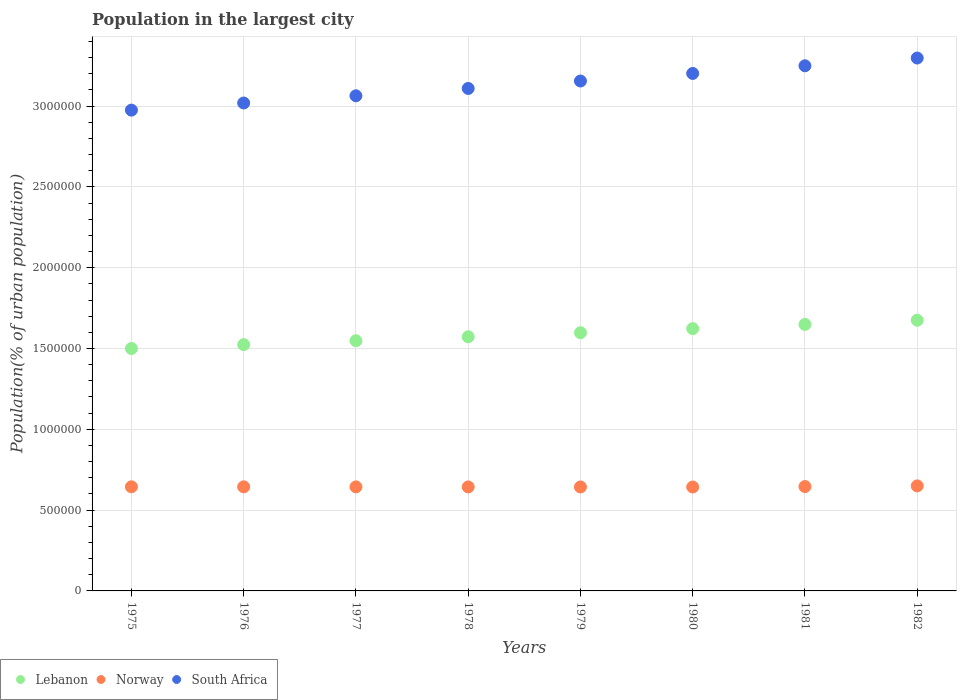How many different coloured dotlines are there?
Offer a very short reply. 3. What is the population in the largest city in Norway in 1982?
Your response must be concise. 6.50e+05. Across all years, what is the maximum population in the largest city in Norway?
Make the answer very short. 6.50e+05. Across all years, what is the minimum population in the largest city in Lebanon?
Give a very brief answer. 1.50e+06. In which year was the population in the largest city in Norway maximum?
Offer a terse response. 1982. In which year was the population in the largest city in Norway minimum?
Offer a very short reply. 1980. What is the total population in the largest city in Norway in the graph?
Give a very brief answer. 5.16e+06. What is the difference between the population in the largest city in Norway in 1976 and that in 1978?
Keep it short and to the point. 491. What is the difference between the population in the largest city in Lebanon in 1981 and the population in the largest city in Norway in 1976?
Give a very brief answer. 1.00e+06. What is the average population in the largest city in Norway per year?
Your answer should be very brief. 6.45e+05. In the year 1980, what is the difference between the population in the largest city in South Africa and population in the largest city in Lebanon?
Provide a succinct answer. 1.58e+06. What is the ratio of the population in the largest city in Norway in 1976 to that in 1978?
Provide a short and direct response. 1. Is the population in the largest city in South Africa in 1977 less than that in 1982?
Your response must be concise. Yes. Is the difference between the population in the largest city in South Africa in 1978 and 1980 greater than the difference between the population in the largest city in Lebanon in 1978 and 1980?
Offer a terse response. No. What is the difference between the highest and the second highest population in the largest city in Norway?
Make the answer very short. 4151. What is the difference between the highest and the lowest population in the largest city in South Africa?
Your answer should be compact. 3.22e+05. In how many years, is the population in the largest city in Norway greater than the average population in the largest city in Norway taken over all years?
Your response must be concise. 2. Is the population in the largest city in Lebanon strictly greater than the population in the largest city in South Africa over the years?
Your answer should be very brief. No. Is the population in the largest city in Norway strictly less than the population in the largest city in South Africa over the years?
Provide a succinct answer. Yes. How many dotlines are there?
Provide a short and direct response. 3. Does the graph contain grids?
Give a very brief answer. Yes. Where does the legend appear in the graph?
Keep it short and to the point. Bottom left. How many legend labels are there?
Your response must be concise. 3. What is the title of the graph?
Your response must be concise. Population in the largest city. Does "Lesotho" appear as one of the legend labels in the graph?
Offer a very short reply. No. What is the label or title of the X-axis?
Your answer should be compact. Years. What is the label or title of the Y-axis?
Provide a short and direct response. Population(% of urban population). What is the Population(% of urban population) in Lebanon in 1975?
Ensure brevity in your answer.  1.50e+06. What is the Population(% of urban population) of Norway in 1975?
Your answer should be very brief. 6.44e+05. What is the Population(% of urban population) of South Africa in 1975?
Your answer should be very brief. 2.97e+06. What is the Population(% of urban population) of Lebanon in 1976?
Your answer should be compact. 1.52e+06. What is the Population(% of urban population) in Norway in 1976?
Ensure brevity in your answer.  6.44e+05. What is the Population(% of urban population) in South Africa in 1976?
Your response must be concise. 3.02e+06. What is the Population(% of urban population) of Lebanon in 1977?
Offer a terse response. 1.55e+06. What is the Population(% of urban population) of Norway in 1977?
Offer a very short reply. 6.44e+05. What is the Population(% of urban population) of South Africa in 1977?
Offer a very short reply. 3.06e+06. What is the Population(% of urban population) of Lebanon in 1978?
Give a very brief answer. 1.57e+06. What is the Population(% of urban population) of Norway in 1978?
Provide a short and direct response. 6.44e+05. What is the Population(% of urban population) in South Africa in 1978?
Offer a terse response. 3.11e+06. What is the Population(% of urban population) in Lebanon in 1979?
Make the answer very short. 1.60e+06. What is the Population(% of urban population) of Norway in 1979?
Give a very brief answer. 6.43e+05. What is the Population(% of urban population) in South Africa in 1979?
Offer a very short reply. 3.16e+06. What is the Population(% of urban population) in Lebanon in 1980?
Your response must be concise. 1.62e+06. What is the Population(% of urban population) in Norway in 1980?
Keep it short and to the point. 6.43e+05. What is the Population(% of urban population) of South Africa in 1980?
Provide a short and direct response. 3.20e+06. What is the Population(% of urban population) of Lebanon in 1981?
Offer a very short reply. 1.65e+06. What is the Population(% of urban population) of Norway in 1981?
Your answer should be compact. 6.46e+05. What is the Population(% of urban population) of South Africa in 1981?
Your answer should be compact. 3.25e+06. What is the Population(% of urban population) in Lebanon in 1982?
Your response must be concise. 1.68e+06. What is the Population(% of urban population) in Norway in 1982?
Offer a terse response. 6.50e+05. What is the Population(% of urban population) in South Africa in 1982?
Give a very brief answer. 3.30e+06. Across all years, what is the maximum Population(% of urban population) of Lebanon?
Make the answer very short. 1.68e+06. Across all years, what is the maximum Population(% of urban population) of Norway?
Offer a terse response. 6.50e+05. Across all years, what is the maximum Population(% of urban population) of South Africa?
Provide a succinct answer. 3.30e+06. Across all years, what is the minimum Population(% of urban population) of Lebanon?
Your answer should be compact. 1.50e+06. Across all years, what is the minimum Population(% of urban population) in Norway?
Your answer should be very brief. 6.43e+05. Across all years, what is the minimum Population(% of urban population) in South Africa?
Your response must be concise. 2.97e+06. What is the total Population(% of urban population) in Lebanon in the graph?
Make the answer very short. 1.27e+07. What is the total Population(% of urban population) in Norway in the graph?
Offer a terse response. 5.16e+06. What is the total Population(% of urban population) of South Africa in the graph?
Ensure brevity in your answer.  2.51e+07. What is the difference between the Population(% of urban population) of Lebanon in 1975 and that in 1976?
Make the answer very short. -2.39e+04. What is the difference between the Population(% of urban population) of Norway in 1975 and that in 1976?
Make the answer very short. 246. What is the difference between the Population(% of urban population) in South Africa in 1975 and that in 1976?
Give a very brief answer. -4.41e+04. What is the difference between the Population(% of urban population) of Lebanon in 1975 and that in 1977?
Offer a very short reply. -4.80e+04. What is the difference between the Population(% of urban population) in Norway in 1975 and that in 1977?
Your answer should be very brief. 491. What is the difference between the Population(% of urban population) of South Africa in 1975 and that in 1977?
Offer a terse response. -8.88e+04. What is the difference between the Population(% of urban population) of Lebanon in 1975 and that in 1978?
Ensure brevity in your answer.  -7.26e+04. What is the difference between the Population(% of urban population) in Norway in 1975 and that in 1978?
Provide a short and direct response. 737. What is the difference between the Population(% of urban population) of South Africa in 1975 and that in 1978?
Make the answer very short. -1.34e+05. What is the difference between the Population(% of urban population) of Lebanon in 1975 and that in 1979?
Your answer should be very brief. -9.76e+04. What is the difference between the Population(% of urban population) of Norway in 1975 and that in 1979?
Ensure brevity in your answer.  983. What is the difference between the Population(% of urban population) in South Africa in 1975 and that in 1979?
Keep it short and to the point. -1.80e+05. What is the difference between the Population(% of urban population) of Lebanon in 1975 and that in 1980?
Ensure brevity in your answer.  -1.23e+05. What is the difference between the Population(% of urban population) in Norway in 1975 and that in 1980?
Offer a terse response. 1229. What is the difference between the Population(% of urban population) of South Africa in 1975 and that in 1980?
Offer a terse response. -2.27e+05. What is the difference between the Population(% of urban population) of Lebanon in 1975 and that in 1981?
Provide a short and direct response. -1.49e+05. What is the difference between the Population(% of urban population) of Norway in 1975 and that in 1981?
Offer a terse response. -1425. What is the difference between the Population(% of urban population) of South Africa in 1975 and that in 1981?
Offer a very short reply. -2.74e+05. What is the difference between the Population(% of urban population) of Lebanon in 1975 and that in 1982?
Your response must be concise. -1.75e+05. What is the difference between the Population(% of urban population) of Norway in 1975 and that in 1982?
Your answer should be compact. -5576. What is the difference between the Population(% of urban population) in South Africa in 1975 and that in 1982?
Provide a short and direct response. -3.22e+05. What is the difference between the Population(% of urban population) of Lebanon in 1976 and that in 1977?
Give a very brief answer. -2.42e+04. What is the difference between the Population(% of urban population) in Norway in 1976 and that in 1977?
Ensure brevity in your answer.  245. What is the difference between the Population(% of urban population) in South Africa in 1976 and that in 1977?
Provide a short and direct response. -4.46e+04. What is the difference between the Population(% of urban population) of Lebanon in 1976 and that in 1978?
Make the answer very short. -4.88e+04. What is the difference between the Population(% of urban population) of Norway in 1976 and that in 1978?
Provide a succinct answer. 491. What is the difference between the Population(% of urban population) of South Africa in 1976 and that in 1978?
Keep it short and to the point. -9.00e+04. What is the difference between the Population(% of urban population) in Lebanon in 1976 and that in 1979?
Keep it short and to the point. -7.38e+04. What is the difference between the Population(% of urban population) in Norway in 1976 and that in 1979?
Offer a terse response. 737. What is the difference between the Population(% of urban population) in South Africa in 1976 and that in 1979?
Offer a terse response. -1.36e+05. What is the difference between the Population(% of urban population) in Lebanon in 1976 and that in 1980?
Give a very brief answer. -9.92e+04. What is the difference between the Population(% of urban population) in Norway in 1976 and that in 1980?
Offer a terse response. 983. What is the difference between the Population(% of urban population) of South Africa in 1976 and that in 1980?
Ensure brevity in your answer.  -1.83e+05. What is the difference between the Population(% of urban population) in Lebanon in 1976 and that in 1981?
Ensure brevity in your answer.  -1.25e+05. What is the difference between the Population(% of urban population) in Norway in 1976 and that in 1981?
Give a very brief answer. -1671. What is the difference between the Population(% of urban population) in South Africa in 1976 and that in 1981?
Keep it short and to the point. -2.30e+05. What is the difference between the Population(% of urban population) in Lebanon in 1976 and that in 1982?
Keep it short and to the point. -1.51e+05. What is the difference between the Population(% of urban population) in Norway in 1976 and that in 1982?
Your answer should be compact. -5822. What is the difference between the Population(% of urban population) in South Africa in 1976 and that in 1982?
Offer a very short reply. -2.78e+05. What is the difference between the Population(% of urban population) of Lebanon in 1977 and that in 1978?
Keep it short and to the point. -2.46e+04. What is the difference between the Population(% of urban population) in Norway in 1977 and that in 1978?
Make the answer very short. 246. What is the difference between the Population(% of urban population) of South Africa in 1977 and that in 1978?
Make the answer very short. -4.54e+04. What is the difference between the Population(% of urban population) in Lebanon in 1977 and that in 1979?
Your response must be concise. -4.96e+04. What is the difference between the Population(% of urban population) in Norway in 1977 and that in 1979?
Provide a short and direct response. 492. What is the difference between the Population(% of urban population) of South Africa in 1977 and that in 1979?
Provide a short and direct response. -9.14e+04. What is the difference between the Population(% of urban population) in Lebanon in 1977 and that in 1980?
Give a very brief answer. -7.50e+04. What is the difference between the Population(% of urban population) in Norway in 1977 and that in 1980?
Give a very brief answer. 738. What is the difference between the Population(% of urban population) of South Africa in 1977 and that in 1980?
Ensure brevity in your answer.  -1.38e+05. What is the difference between the Population(% of urban population) of Lebanon in 1977 and that in 1981?
Make the answer very short. -1.01e+05. What is the difference between the Population(% of urban population) in Norway in 1977 and that in 1981?
Provide a succinct answer. -1916. What is the difference between the Population(% of urban population) of South Africa in 1977 and that in 1981?
Your answer should be compact. -1.86e+05. What is the difference between the Population(% of urban population) in Lebanon in 1977 and that in 1982?
Keep it short and to the point. -1.27e+05. What is the difference between the Population(% of urban population) of Norway in 1977 and that in 1982?
Your response must be concise. -6067. What is the difference between the Population(% of urban population) in South Africa in 1977 and that in 1982?
Ensure brevity in your answer.  -2.34e+05. What is the difference between the Population(% of urban population) of Lebanon in 1978 and that in 1979?
Your answer should be very brief. -2.50e+04. What is the difference between the Population(% of urban population) of Norway in 1978 and that in 1979?
Give a very brief answer. 246. What is the difference between the Population(% of urban population) of South Africa in 1978 and that in 1979?
Keep it short and to the point. -4.60e+04. What is the difference between the Population(% of urban population) in Lebanon in 1978 and that in 1980?
Provide a short and direct response. -5.04e+04. What is the difference between the Population(% of urban population) of Norway in 1978 and that in 1980?
Provide a succinct answer. 492. What is the difference between the Population(% of urban population) of South Africa in 1978 and that in 1980?
Your answer should be very brief. -9.28e+04. What is the difference between the Population(% of urban population) in Lebanon in 1978 and that in 1981?
Offer a terse response. -7.62e+04. What is the difference between the Population(% of urban population) in Norway in 1978 and that in 1981?
Give a very brief answer. -2162. What is the difference between the Population(% of urban population) in South Africa in 1978 and that in 1981?
Offer a terse response. -1.40e+05. What is the difference between the Population(% of urban population) of Lebanon in 1978 and that in 1982?
Your answer should be very brief. -1.02e+05. What is the difference between the Population(% of urban population) of Norway in 1978 and that in 1982?
Make the answer very short. -6313. What is the difference between the Population(% of urban population) of South Africa in 1978 and that in 1982?
Your response must be concise. -1.88e+05. What is the difference between the Population(% of urban population) of Lebanon in 1979 and that in 1980?
Your answer should be very brief. -2.54e+04. What is the difference between the Population(% of urban population) of Norway in 1979 and that in 1980?
Give a very brief answer. 246. What is the difference between the Population(% of urban population) of South Africa in 1979 and that in 1980?
Ensure brevity in your answer.  -4.68e+04. What is the difference between the Population(% of urban population) in Lebanon in 1979 and that in 1981?
Keep it short and to the point. -5.12e+04. What is the difference between the Population(% of urban population) of Norway in 1979 and that in 1981?
Provide a succinct answer. -2408. What is the difference between the Population(% of urban population) of South Africa in 1979 and that in 1981?
Provide a succinct answer. -9.41e+04. What is the difference between the Population(% of urban population) of Lebanon in 1979 and that in 1982?
Offer a very short reply. -7.74e+04. What is the difference between the Population(% of urban population) of Norway in 1979 and that in 1982?
Your answer should be compact. -6559. What is the difference between the Population(% of urban population) of South Africa in 1979 and that in 1982?
Offer a very short reply. -1.42e+05. What is the difference between the Population(% of urban population) in Lebanon in 1980 and that in 1981?
Provide a succinct answer. -2.58e+04. What is the difference between the Population(% of urban population) of Norway in 1980 and that in 1981?
Make the answer very short. -2654. What is the difference between the Population(% of urban population) of South Africa in 1980 and that in 1981?
Keep it short and to the point. -4.74e+04. What is the difference between the Population(% of urban population) of Lebanon in 1980 and that in 1982?
Make the answer very short. -5.20e+04. What is the difference between the Population(% of urban population) in Norway in 1980 and that in 1982?
Provide a succinct answer. -6805. What is the difference between the Population(% of urban population) in South Africa in 1980 and that in 1982?
Your response must be concise. -9.55e+04. What is the difference between the Population(% of urban population) in Lebanon in 1981 and that in 1982?
Your answer should be compact. -2.62e+04. What is the difference between the Population(% of urban population) in Norway in 1981 and that in 1982?
Keep it short and to the point. -4151. What is the difference between the Population(% of urban population) of South Africa in 1981 and that in 1982?
Your answer should be very brief. -4.81e+04. What is the difference between the Population(% of urban population) of Lebanon in 1975 and the Population(% of urban population) of Norway in 1976?
Give a very brief answer. 8.56e+05. What is the difference between the Population(% of urban population) in Lebanon in 1975 and the Population(% of urban population) in South Africa in 1976?
Your response must be concise. -1.52e+06. What is the difference between the Population(% of urban population) of Norway in 1975 and the Population(% of urban population) of South Africa in 1976?
Provide a succinct answer. -2.37e+06. What is the difference between the Population(% of urban population) of Lebanon in 1975 and the Population(% of urban population) of Norway in 1977?
Ensure brevity in your answer.  8.56e+05. What is the difference between the Population(% of urban population) of Lebanon in 1975 and the Population(% of urban population) of South Africa in 1977?
Ensure brevity in your answer.  -1.56e+06. What is the difference between the Population(% of urban population) in Norway in 1975 and the Population(% of urban population) in South Africa in 1977?
Your response must be concise. -2.42e+06. What is the difference between the Population(% of urban population) in Lebanon in 1975 and the Population(% of urban population) in Norway in 1978?
Your answer should be very brief. 8.56e+05. What is the difference between the Population(% of urban population) of Lebanon in 1975 and the Population(% of urban population) of South Africa in 1978?
Keep it short and to the point. -1.61e+06. What is the difference between the Population(% of urban population) in Norway in 1975 and the Population(% of urban population) in South Africa in 1978?
Keep it short and to the point. -2.46e+06. What is the difference between the Population(% of urban population) of Lebanon in 1975 and the Population(% of urban population) of Norway in 1979?
Your answer should be compact. 8.57e+05. What is the difference between the Population(% of urban population) in Lebanon in 1975 and the Population(% of urban population) in South Africa in 1979?
Keep it short and to the point. -1.66e+06. What is the difference between the Population(% of urban population) of Norway in 1975 and the Population(% of urban population) of South Africa in 1979?
Your response must be concise. -2.51e+06. What is the difference between the Population(% of urban population) in Lebanon in 1975 and the Population(% of urban population) in Norway in 1980?
Ensure brevity in your answer.  8.57e+05. What is the difference between the Population(% of urban population) of Lebanon in 1975 and the Population(% of urban population) of South Africa in 1980?
Your response must be concise. -1.70e+06. What is the difference between the Population(% of urban population) of Norway in 1975 and the Population(% of urban population) of South Africa in 1980?
Give a very brief answer. -2.56e+06. What is the difference between the Population(% of urban population) of Lebanon in 1975 and the Population(% of urban population) of Norway in 1981?
Your response must be concise. 8.54e+05. What is the difference between the Population(% of urban population) of Lebanon in 1975 and the Population(% of urban population) of South Africa in 1981?
Give a very brief answer. -1.75e+06. What is the difference between the Population(% of urban population) in Norway in 1975 and the Population(% of urban population) in South Africa in 1981?
Provide a short and direct response. -2.60e+06. What is the difference between the Population(% of urban population) of Lebanon in 1975 and the Population(% of urban population) of Norway in 1982?
Your answer should be very brief. 8.50e+05. What is the difference between the Population(% of urban population) in Lebanon in 1975 and the Population(% of urban population) in South Africa in 1982?
Offer a terse response. -1.80e+06. What is the difference between the Population(% of urban population) in Norway in 1975 and the Population(% of urban population) in South Africa in 1982?
Keep it short and to the point. -2.65e+06. What is the difference between the Population(% of urban population) in Lebanon in 1976 and the Population(% of urban population) in Norway in 1977?
Offer a very short reply. 8.80e+05. What is the difference between the Population(% of urban population) of Lebanon in 1976 and the Population(% of urban population) of South Africa in 1977?
Offer a terse response. -1.54e+06. What is the difference between the Population(% of urban population) of Norway in 1976 and the Population(% of urban population) of South Africa in 1977?
Give a very brief answer. -2.42e+06. What is the difference between the Population(% of urban population) of Lebanon in 1976 and the Population(% of urban population) of Norway in 1978?
Provide a succinct answer. 8.80e+05. What is the difference between the Population(% of urban population) of Lebanon in 1976 and the Population(% of urban population) of South Africa in 1978?
Offer a very short reply. -1.59e+06. What is the difference between the Population(% of urban population) in Norway in 1976 and the Population(% of urban population) in South Africa in 1978?
Give a very brief answer. -2.47e+06. What is the difference between the Population(% of urban population) of Lebanon in 1976 and the Population(% of urban population) of Norway in 1979?
Offer a terse response. 8.81e+05. What is the difference between the Population(% of urban population) in Lebanon in 1976 and the Population(% of urban population) in South Africa in 1979?
Give a very brief answer. -1.63e+06. What is the difference between the Population(% of urban population) in Norway in 1976 and the Population(% of urban population) in South Africa in 1979?
Your answer should be compact. -2.51e+06. What is the difference between the Population(% of urban population) of Lebanon in 1976 and the Population(% of urban population) of Norway in 1980?
Ensure brevity in your answer.  8.81e+05. What is the difference between the Population(% of urban population) in Lebanon in 1976 and the Population(% of urban population) in South Africa in 1980?
Offer a terse response. -1.68e+06. What is the difference between the Population(% of urban population) in Norway in 1976 and the Population(% of urban population) in South Africa in 1980?
Make the answer very short. -2.56e+06. What is the difference between the Population(% of urban population) in Lebanon in 1976 and the Population(% of urban population) in Norway in 1981?
Offer a terse response. 8.78e+05. What is the difference between the Population(% of urban population) in Lebanon in 1976 and the Population(% of urban population) in South Africa in 1981?
Your answer should be compact. -1.73e+06. What is the difference between the Population(% of urban population) in Norway in 1976 and the Population(% of urban population) in South Africa in 1981?
Your answer should be very brief. -2.61e+06. What is the difference between the Population(% of urban population) in Lebanon in 1976 and the Population(% of urban population) in Norway in 1982?
Give a very brief answer. 8.74e+05. What is the difference between the Population(% of urban population) in Lebanon in 1976 and the Population(% of urban population) in South Africa in 1982?
Give a very brief answer. -1.77e+06. What is the difference between the Population(% of urban population) of Norway in 1976 and the Population(% of urban population) of South Africa in 1982?
Your answer should be very brief. -2.65e+06. What is the difference between the Population(% of urban population) of Lebanon in 1977 and the Population(% of urban population) of Norway in 1978?
Provide a short and direct response. 9.05e+05. What is the difference between the Population(% of urban population) in Lebanon in 1977 and the Population(% of urban population) in South Africa in 1978?
Ensure brevity in your answer.  -1.56e+06. What is the difference between the Population(% of urban population) of Norway in 1977 and the Population(% of urban population) of South Africa in 1978?
Your answer should be compact. -2.47e+06. What is the difference between the Population(% of urban population) of Lebanon in 1977 and the Population(% of urban population) of Norway in 1979?
Provide a succinct answer. 9.05e+05. What is the difference between the Population(% of urban population) of Lebanon in 1977 and the Population(% of urban population) of South Africa in 1979?
Your answer should be compact. -1.61e+06. What is the difference between the Population(% of urban population) of Norway in 1977 and the Population(% of urban population) of South Africa in 1979?
Ensure brevity in your answer.  -2.51e+06. What is the difference between the Population(% of urban population) in Lebanon in 1977 and the Population(% of urban population) in Norway in 1980?
Your answer should be very brief. 9.05e+05. What is the difference between the Population(% of urban population) in Lebanon in 1977 and the Population(% of urban population) in South Africa in 1980?
Offer a very short reply. -1.65e+06. What is the difference between the Population(% of urban population) of Norway in 1977 and the Population(% of urban population) of South Africa in 1980?
Provide a succinct answer. -2.56e+06. What is the difference between the Population(% of urban population) in Lebanon in 1977 and the Population(% of urban population) in Norway in 1981?
Offer a terse response. 9.02e+05. What is the difference between the Population(% of urban population) of Lebanon in 1977 and the Population(% of urban population) of South Africa in 1981?
Your response must be concise. -1.70e+06. What is the difference between the Population(% of urban population) of Norway in 1977 and the Population(% of urban population) of South Africa in 1981?
Your answer should be very brief. -2.61e+06. What is the difference between the Population(% of urban population) in Lebanon in 1977 and the Population(% of urban population) in Norway in 1982?
Your answer should be very brief. 8.98e+05. What is the difference between the Population(% of urban population) in Lebanon in 1977 and the Population(% of urban population) in South Africa in 1982?
Your answer should be very brief. -1.75e+06. What is the difference between the Population(% of urban population) in Norway in 1977 and the Population(% of urban population) in South Africa in 1982?
Your answer should be compact. -2.65e+06. What is the difference between the Population(% of urban population) of Lebanon in 1978 and the Population(% of urban population) of Norway in 1979?
Provide a succinct answer. 9.29e+05. What is the difference between the Population(% of urban population) of Lebanon in 1978 and the Population(% of urban population) of South Africa in 1979?
Your answer should be very brief. -1.58e+06. What is the difference between the Population(% of urban population) in Norway in 1978 and the Population(% of urban population) in South Africa in 1979?
Provide a short and direct response. -2.51e+06. What is the difference between the Population(% of urban population) in Lebanon in 1978 and the Population(% of urban population) in Norway in 1980?
Give a very brief answer. 9.30e+05. What is the difference between the Population(% of urban population) of Lebanon in 1978 and the Population(% of urban population) of South Africa in 1980?
Your answer should be compact. -1.63e+06. What is the difference between the Population(% of urban population) in Norway in 1978 and the Population(% of urban population) in South Africa in 1980?
Provide a short and direct response. -2.56e+06. What is the difference between the Population(% of urban population) in Lebanon in 1978 and the Population(% of urban population) in Norway in 1981?
Keep it short and to the point. 9.27e+05. What is the difference between the Population(% of urban population) in Lebanon in 1978 and the Population(% of urban population) in South Africa in 1981?
Offer a very short reply. -1.68e+06. What is the difference between the Population(% of urban population) of Norway in 1978 and the Population(% of urban population) of South Africa in 1981?
Offer a very short reply. -2.61e+06. What is the difference between the Population(% of urban population) in Lebanon in 1978 and the Population(% of urban population) in Norway in 1982?
Keep it short and to the point. 9.23e+05. What is the difference between the Population(% of urban population) in Lebanon in 1978 and the Population(% of urban population) in South Africa in 1982?
Make the answer very short. -1.72e+06. What is the difference between the Population(% of urban population) of Norway in 1978 and the Population(% of urban population) of South Africa in 1982?
Offer a very short reply. -2.65e+06. What is the difference between the Population(% of urban population) in Lebanon in 1979 and the Population(% of urban population) in Norway in 1980?
Your answer should be very brief. 9.55e+05. What is the difference between the Population(% of urban population) of Lebanon in 1979 and the Population(% of urban population) of South Africa in 1980?
Offer a terse response. -1.60e+06. What is the difference between the Population(% of urban population) of Norway in 1979 and the Population(% of urban population) of South Africa in 1980?
Offer a very short reply. -2.56e+06. What is the difference between the Population(% of urban population) of Lebanon in 1979 and the Population(% of urban population) of Norway in 1981?
Your answer should be very brief. 9.52e+05. What is the difference between the Population(% of urban population) of Lebanon in 1979 and the Population(% of urban population) of South Africa in 1981?
Provide a succinct answer. -1.65e+06. What is the difference between the Population(% of urban population) of Norway in 1979 and the Population(% of urban population) of South Africa in 1981?
Offer a very short reply. -2.61e+06. What is the difference between the Population(% of urban population) in Lebanon in 1979 and the Population(% of urban population) in Norway in 1982?
Provide a succinct answer. 9.48e+05. What is the difference between the Population(% of urban population) of Lebanon in 1979 and the Population(% of urban population) of South Africa in 1982?
Your answer should be compact. -1.70e+06. What is the difference between the Population(% of urban population) of Norway in 1979 and the Population(% of urban population) of South Africa in 1982?
Your answer should be compact. -2.65e+06. What is the difference between the Population(% of urban population) in Lebanon in 1980 and the Population(% of urban population) in Norway in 1981?
Your answer should be compact. 9.77e+05. What is the difference between the Population(% of urban population) of Lebanon in 1980 and the Population(% of urban population) of South Africa in 1981?
Provide a short and direct response. -1.63e+06. What is the difference between the Population(% of urban population) in Norway in 1980 and the Population(% of urban population) in South Africa in 1981?
Ensure brevity in your answer.  -2.61e+06. What is the difference between the Population(% of urban population) in Lebanon in 1980 and the Population(% of urban population) in Norway in 1982?
Ensure brevity in your answer.  9.73e+05. What is the difference between the Population(% of urban population) in Lebanon in 1980 and the Population(% of urban population) in South Africa in 1982?
Give a very brief answer. -1.67e+06. What is the difference between the Population(% of urban population) in Norway in 1980 and the Population(% of urban population) in South Africa in 1982?
Make the answer very short. -2.65e+06. What is the difference between the Population(% of urban population) in Lebanon in 1981 and the Population(% of urban population) in Norway in 1982?
Keep it short and to the point. 9.99e+05. What is the difference between the Population(% of urban population) in Lebanon in 1981 and the Population(% of urban population) in South Africa in 1982?
Ensure brevity in your answer.  -1.65e+06. What is the difference between the Population(% of urban population) of Norway in 1981 and the Population(% of urban population) of South Africa in 1982?
Provide a short and direct response. -2.65e+06. What is the average Population(% of urban population) of Lebanon per year?
Your answer should be very brief. 1.59e+06. What is the average Population(% of urban population) of Norway per year?
Provide a succinct answer. 6.45e+05. What is the average Population(% of urban population) of South Africa per year?
Your answer should be very brief. 3.13e+06. In the year 1975, what is the difference between the Population(% of urban population) of Lebanon and Population(% of urban population) of Norway?
Give a very brief answer. 8.56e+05. In the year 1975, what is the difference between the Population(% of urban population) of Lebanon and Population(% of urban population) of South Africa?
Your response must be concise. -1.47e+06. In the year 1975, what is the difference between the Population(% of urban population) in Norway and Population(% of urban population) in South Africa?
Provide a short and direct response. -2.33e+06. In the year 1976, what is the difference between the Population(% of urban population) in Lebanon and Population(% of urban population) in Norway?
Keep it short and to the point. 8.80e+05. In the year 1976, what is the difference between the Population(% of urban population) of Lebanon and Population(% of urban population) of South Africa?
Keep it short and to the point. -1.50e+06. In the year 1976, what is the difference between the Population(% of urban population) in Norway and Population(% of urban population) in South Africa?
Your answer should be very brief. -2.38e+06. In the year 1977, what is the difference between the Population(% of urban population) of Lebanon and Population(% of urban population) of Norway?
Your answer should be compact. 9.04e+05. In the year 1977, what is the difference between the Population(% of urban population) in Lebanon and Population(% of urban population) in South Africa?
Offer a very short reply. -1.52e+06. In the year 1977, what is the difference between the Population(% of urban population) in Norway and Population(% of urban population) in South Africa?
Keep it short and to the point. -2.42e+06. In the year 1978, what is the difference between the Population(% of urban population) in Lebanon and Population(% of urban population) in Norway?
Ensure brevity in your answer.  9.29e+05. In the year 1978, what is the difference between the Population(% of urban population) in Lebanon and Population(% of urban population) in South Africa?
Offer a very short reply. -1.54e+06. In the year 1978, what is the difference between the Population(% of urban population) of Norway and Population(% of urban population) of South Africa?
Your answer should be compact. -2.47e+06. In the year 1979, what is the difference between the Population(% of urban population) in Lebanon and Population(% of urban population) in Norway?
Offer a very short reply. 9.54e+05. In the year 1979, what is the difference between the Population(% of urban population) in Lebanon and Population(% of urban population) in South Africa?
Your answer should be compact. -1.56e+06. In the year 1979, what is the difference between the Population(% of urban population) of Norway and Population(% of urban population) of South Africa?
Make the answer very short. -2.51e+06. In the year 1980, what is the difference between the Population(% of urban population) in Lebanon and Population(% of urban population) in Norway?
Provide a succinct answer. 9.80e+05. In the year 1980, what is the difference between the Population(% of urban population) of Lebanon and Population(% of urban population) of South Africa?
Make the answer very short. -1.58e+06. In the year 1980, what is the difference between the Population(% of urban population) of Norway and Population(% of urban population) of South Africa?
Ensure brevity in your answer.  -2.56e+06. In the year 1981, what is the difference between the Population(% of urban population) in Lebanon and Population(% of urban population) in Norway?
Offer a terse response. 1.00e+06. In the year 1981, what is the difference between the Population(% of urban population) of Lebanon and Population(% of urban population) of South Africa?
Provide a succinct answer. -1.60e+06. In the year 1981, what is the difference between the Population(% of urban population) in Norway and Population(% of urban population) in South Africa?
Your answer should be compact. -2.60e+06. In the year 1982, what is the difference between the Population(% of urban population) in Lebanon and Population(% of urban population) in Norway?
Your response must be concise. 1.03e+06. In the year 1982, what is the difference between the Population(% of urban population) of Lebanon and Population(% of urban population) of South Africa?
Give a very brief answer. -1.62e+06. In the year 1982, what is the difference between the Population(% of urban population) in Norway and Population(% of urban population) in South Africa?
Make the answer very short. -2.65e+06. What is the ratio of the Population(% of urban population) of Lebanon in 1975 to that in 1976?
Your answer should be very brief. 0.98. What is the ratio of the Population(% of urban population) in Norway in 1975 to that in 1976?
Your answer should be very brief. 1. What is the ratio of the Population(% of urban population) of South Africa in 1975 to that in 1976?
Offer a terse response. 0.99. What is the ratio of the Population(% of urban population) in Lebanon in 1975 to that in 1977?
Provide a short and direct response. 0.97. What is the ratio of the Population(% of urban population) of Norway in 1975 to that in 1977?
Keep it short and to the point. 1. What is the ratio of the Population(% of urban population) of South Africa in 1975 to that in 1977?
Make the answer very short. 0.97. What is the ratio of the Population(% of urban population) in Lebanon in 1975 to that in 1978?
Make the answer very short. 0.95. What is the ratio of the Population(% of urban population) in South Africa in 1975 to that in 1978?
Your answer should be compact. 0.96. What is the ratio of the Population(% of urban population) in Lebanon in 1975 to that in 1979?
Your answer should be compact. 0.94. What is the ratio of the Population(% of urban population) of South Africa in 1975 to that in 1979?
Offer a terse response. 0.94. What is the ratio of the Population(% of urban population) in Lebanon in 1975 to that in 1980?
Your answer should be very brief. 0.92. What is the ratio of the Population(% of urban population) of South Africa in 1975 to that in 1980?
Make the answer very short. 0.93. What is the ratio of the Population(% of urban population) in Lebanon in 1975 to that in 1981?
Offer a very short reply. 0.91. What is the ratio of the Population(% of urban population) of South Africa in 1975 to that in 1981?
Keep it short and to the point. 0.92. What is the ratio of the Population(% of urban population) of Lebanon in 1975 to that in 1982?
Provide a succinct answer. 0.9. What is the ratio of the Population(% of urban population) in Norway in 1975 to that in 1982?
Ensure brevity in your answer.  0.99. What is the ratio of the Population(% of urban population) in South Africa in 1975 to that in 1982?
Make the answer very short. 0.9. What is the ratio of the Population(% of urban population) in Lebanon in 1976 to that in 1977?
Offer a terse response. 0.98. What is the ratio of the Population(% of urban population) of Norway in 1976 to that in 1977?
Your response must be concise. 1. What is the ratio of the Population(% of urban population) in South Africa in 1976 to that in 1977?
Provide a short and direct response. 0.99. What is the ratio of the Population(% of urban population) of Norway in 1976 to that in 1978?
Your answer should be compact. 1. What is the ratio of the Population(% of urban population) of Lebanon in 1976 to that in 1979?
Ensure brevity in your answer.  0.95. What is the ratio of the Population(% of urban population) in South Africa in 1976 to that in 1979?
Give a very brief answer. 0.96. What is the ratio of the Population(% of urban population) in Lebanon in 1976 to that in 1980?
Provide a short and direct response. 0.94. What is the ratio of the Population(% of urban population) of Norway in 1976 to that in 1980?
Ensure brevity in your answer.  1. What is the ratio of the Population(% of urban population) in South Africa in 1976 to that in 1980?
Offer a very short reply. 0.94. What is the ratio of the Population(% of urban population) of Lebanon in 1976 to that in 1981?
Your answer should be compact. 0.92. What is the ratio of the Population(% of urban population) of South Africa in 1976 to that in 1981?
Your response must be concise. 0.93. What is the ratio of the Population(% of urban population) in Lebanon in 1976 to that in 1982?
Give a very brief answer. 0.91. What is the ratio of the Population(% of urban population) of Norway in 1976 to that in 1982?
Offer a terse response. 0.99. What is the ratio of the Population(% of urban population) in South Africa in 1976 to that in 1982?
Your answer should be very brief. 0.92. What is the ratio of the Population(% of urban population) in Lebanon in 1977 to that in 1978?
Give a very brief answer. 0.98. What is the ratio of the Population(% of urban population) of Norway in 1977 to that in 1978?
Make the answer very short. 1. What is the ratio of the Population(% of urban population) of South Africa in 1977 to that in 1978?
Offer a terse response. 0.99. What is the ratio of the Population(% of urban population) of Lebanon in 1977 to that in 1979?
Your answer should be very brief. 0.97. What is the ratio of the Population(% of urban population) in Norway in 1977 to that in 1979?
Provide a succinct answer. 1. What is the ratio of the Population(% of urban population) of South Africa in 1977 to that in 1979?
Offer a terse response. 0.97. What is the ratio of the Population(% of urban population) of Lebanon in 1977 to that in 1980?
Give a very brief answer. 0.95. What is the ratio of the Population(% of urban population) of Norway in 1977 to that in 1980?
Give a very brief answer. 1. What is the ratio of the Population(% of urban population) of South Africa in 1977 to that in 1980?
Your response must be concise. 0.96. What is the ratio of the Population(% of urban population) in Lebanon in 1977 to that in 1981?
Provide a succinct answer. 0.94. What is the ratio of the Population(% of urban population) in South Africa in 1977 to that in 1981?
Your answer should be compact. 0.94. What is the ratio of the Population(% of urban population) of Lebanon in 1977 to that in 1982?
Offer a very short reply. 0.92. What is the ratio of the Population(% of urban population) of South Africa in 1977 to that in 1982?
Make the answer very short. 0.93. What is the ratio of the Population(% of urban population) of Lebanon in 1978 to that in 1979?
Your answer should be very brief. 0.98. What is the ratio of the Population(% of urban population) of South Africa in 1978 to that in 1979?
Your answer should be very brief. 0.99. What is the ratio of the Population(% of urban population) of Lebanon in 1978 to that in 1980?
Ensure brevity in your answer.  0.97. What is the ratio of the Population(% of urban population) in Norway in 1978 to that in 1980?
Ensure brevity in your answer.  1. What is the ratio of the Population(% of urban population) in Lebanon in 1978 to that in 1981?
Ensure brevity in your answer.  0.95. What is the ratio of the Population(% of urban population) in Norway in 1978 to that in 1981?
Your answer should be very brief. 1. What is the ratio of the Population(% of urban population) of South Africa in 1978 to that in 1981?
Make the answer very short. 0.96. What is the ratio of the Population(% of urban population) of Lebanon in 1978 to that in 1982?
Keep it short and to the point. 0.94. What is the ratio of the Population(% of urban population) in Norway in 1978 to that in 1982?
Provide a succinct answer. 0.99. What is the ratio of the Population(% of urban population) in South Africa in 1978 to that in 1982?
Ensure brevity in your answer.  0.94. What is the ratio of the Population(% of urban population) in Lebanon in 1979 to that in 1980?
Offer a terse response. 0.98. What is the ratio of the Population(% of urban population) in South Africa in 1979 to that in 1980?
Your answer should be very brief. 0.99. What is the ratio of the Population(% of urban population) of Lebanon in 1979 to that in 1981?
Provide a succinct answer. 0.97. What is the ratio of the Population(% of urban population) in South Africa in 1979 to that in 1981?
Offer a very short reply. 0.97. What is the ratio of the Population(% of urban population) in Lebanon in 1979 to that in 1982?
Offer a terse response. 0.95. What is the ratio of the Population(% of urban population) of Norway in 1979 to that in 1982?
Keep it short and to the point. 0.99. What is the ratio of the Population(% of urban population) in South Africa in 1979 to that in 1982?
Give a very brief answer. 0.96. What is the ratio of the Population(% of urban population) of Lebanon in 1980 to that in 1981?
Offer a very short reply. 0.98. What is the ratio of the Population(% of urban population) of Norway in 1980 to that in 1981?
Provide a succinct answer. 1. What is the ratio of the Population(% of urban population) of South Africa in 1980 to that in 1981?
Provide a short and direct response. 0.99. What is the ratio of the Population(% of urban population) of Lebanon in 1980 to that in 1982?
Keep it short and to the point. 0.97. What is the ratio of the Population(% of urban population) of Norway in 1980 to that in 1982?
Offer a terse response. 0.99. What is the ratio of the Population(% of urban population) in Lebanon in 1981 to that in 1982?
Offer a terse response. 0.98. What is the ratio of the Population(% of urban population) in South Africa in 1981 to that in 1982?
Give a very brief answer. 0.99. What is the difference between the highest and the second highest Population(% of urban population) in Lebanon?
Your answer should be very brief. 2.62e+04. What is the difference between the highest and the second highest Population(% of urban population) in Norway?
Your response must be concise. 4151. What is the difference between the highest and the second highest Population(% of urban population) of South Africa?
Make the answer very short. 4.81e+04. What is the difference between the highest and the lowest Population(% of urban population) in Lebanon?
Your answer should be very brief. 1.75e+05. What is the difference between the highest and the lowest Population(% of urban population) in Norway?
Provide a short and direct response. 6805. What is the difference between the highest and the lowest Population(% of urban population) in South Africa?
Your response must be concise. 3.22e+05. 